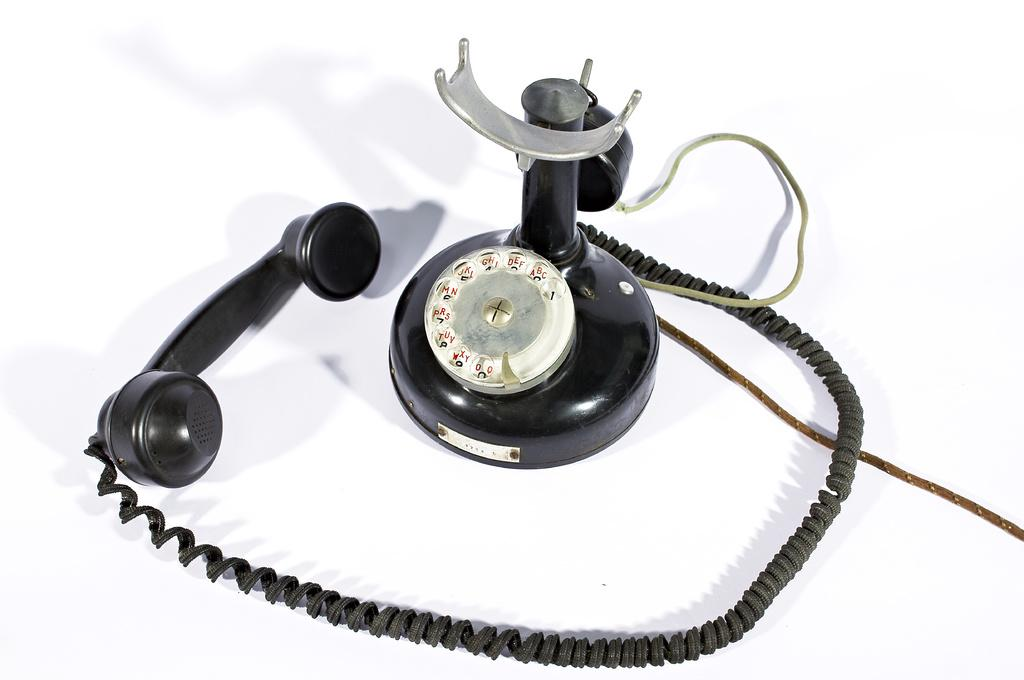What type of telephone is visible in the image? There is a black color telephone in the image. What else can be seen in the image besides the telephone? There is a thread on a white surface in the image. Can you see an owl sitting on the door in the image? There is no owl or door present in the image. What show is being broadcasted on the telephone in the image? Telephones do not broadcast shows; they are used for communication. 